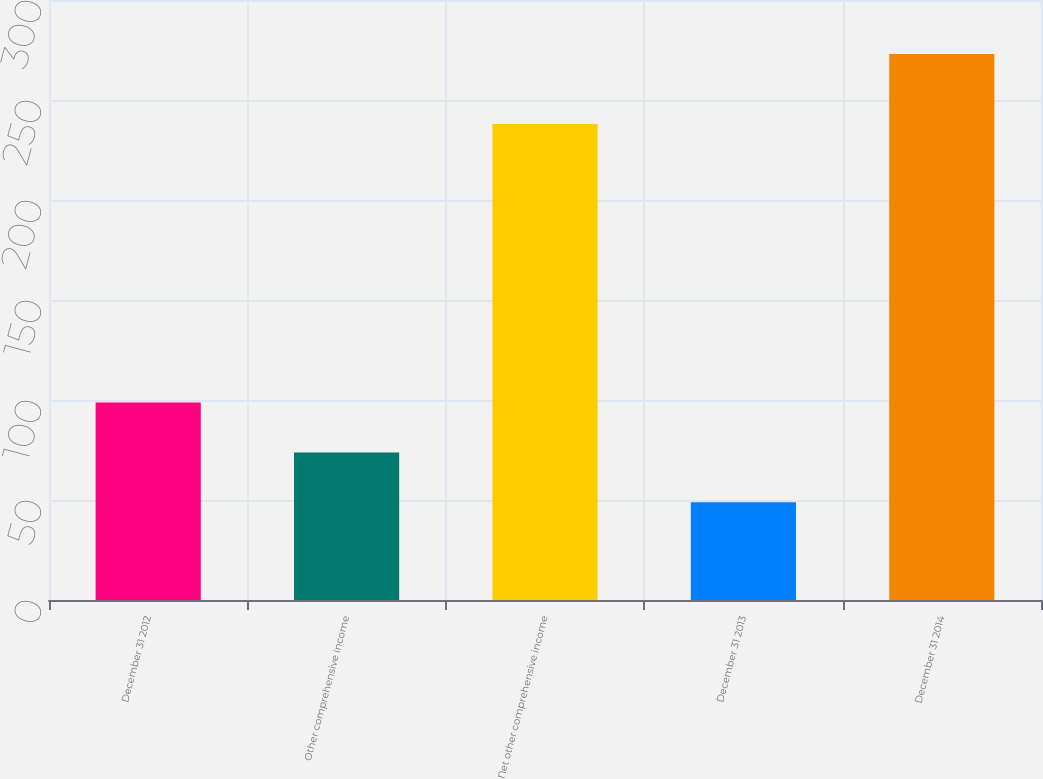<chart> <loc_0><loc_0><loc_500><loc_500><bar_chart><fcel>December 31 2012<fcel>Other comprehensive income<fcel>Net other comprehensive income<fcel>December 31 2013<fcel>December 31 2014<nl><fcel>98.7<fcel>73.8<fcel>238<fcel>48.9<fcel>273<nl></chart> 